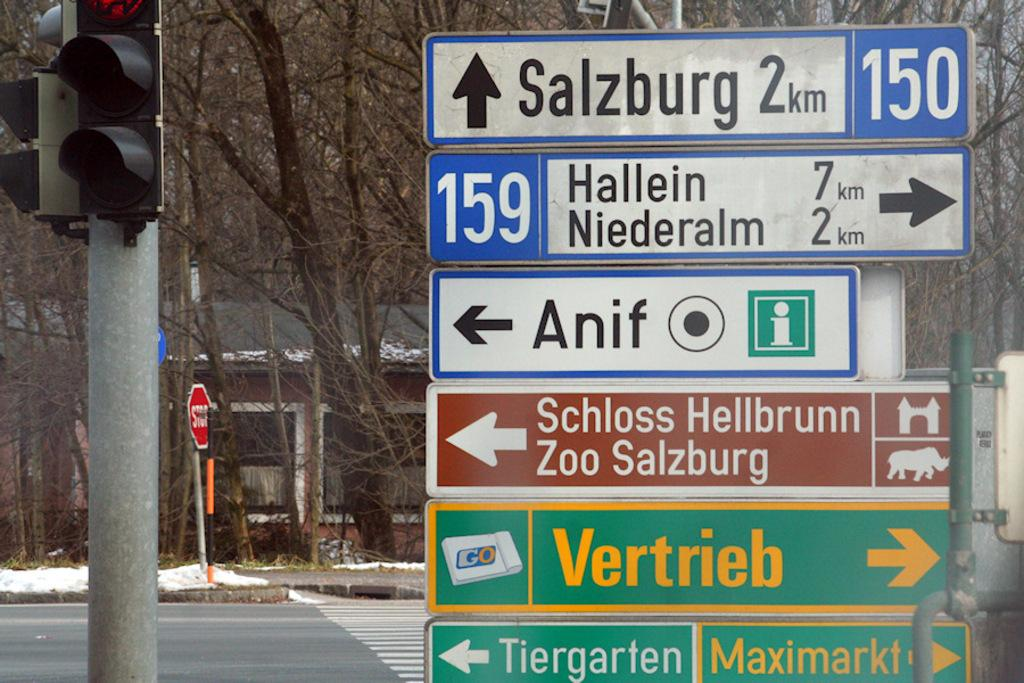<image>
Summarize the visual content of the image. Multiple directional signs are posted, including Salzburg 2 km. 